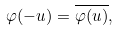Convert formula to latex. <formula><loc_0><loc_0><loc_500><loc_500>\varphi ( - u ) = \overline { \varphi ( u ) } ,</formula> 